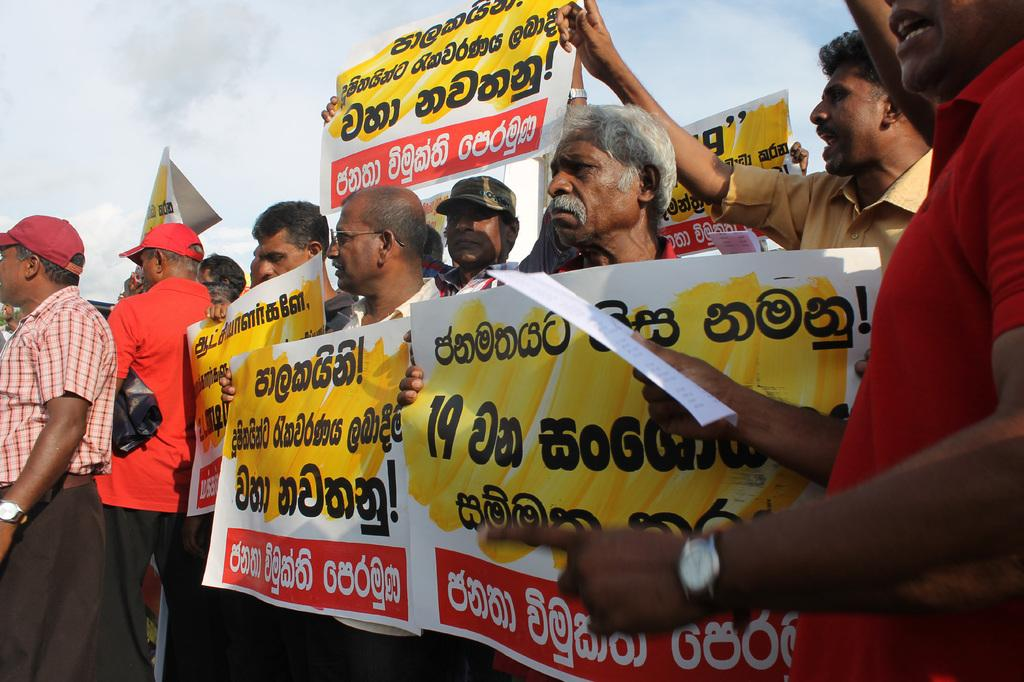What can be seen in the foreground of the image? There are people in the foreground of the image. What are the people holding in their hands? The people are holding posters in their hands. What is written on the posters? There is text on the posters. What is visible in the background of the image? The sky is visible in the background of the image. Where is the pear located in the image? There is no pear present in the image. What type of wall can be seen in the image? There is no wall present in the image. 